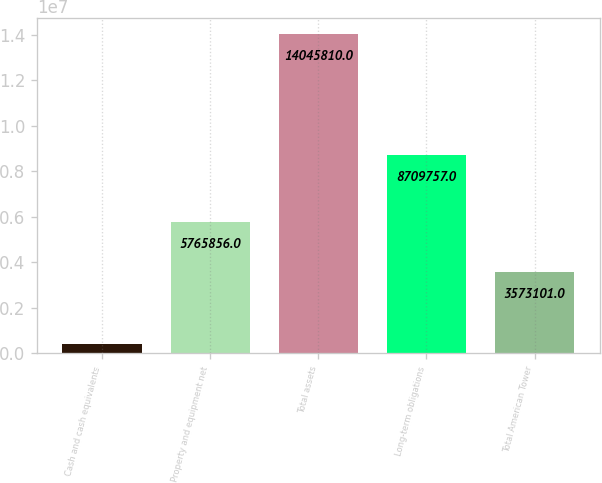Convert chart. <chart><loc_0><loc_0><loc_500><loc_500><bar_chart><fcel>Cash and cash equivalents<fcel>Property and equipment net<fcel>Total assets<fcel>Long-term obligations<fcel>Total American Tower<nl><fcel>437934<fcel>5.76586e+06<fcel>1.40458e+07<fcel>8.70976e+06<fcel>3.5731e+06<nl></chart> 